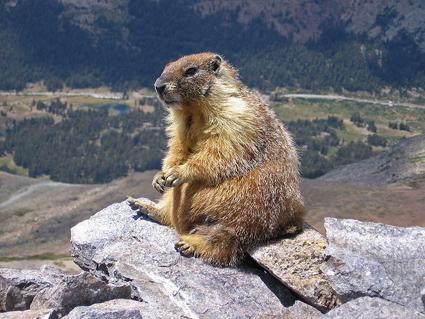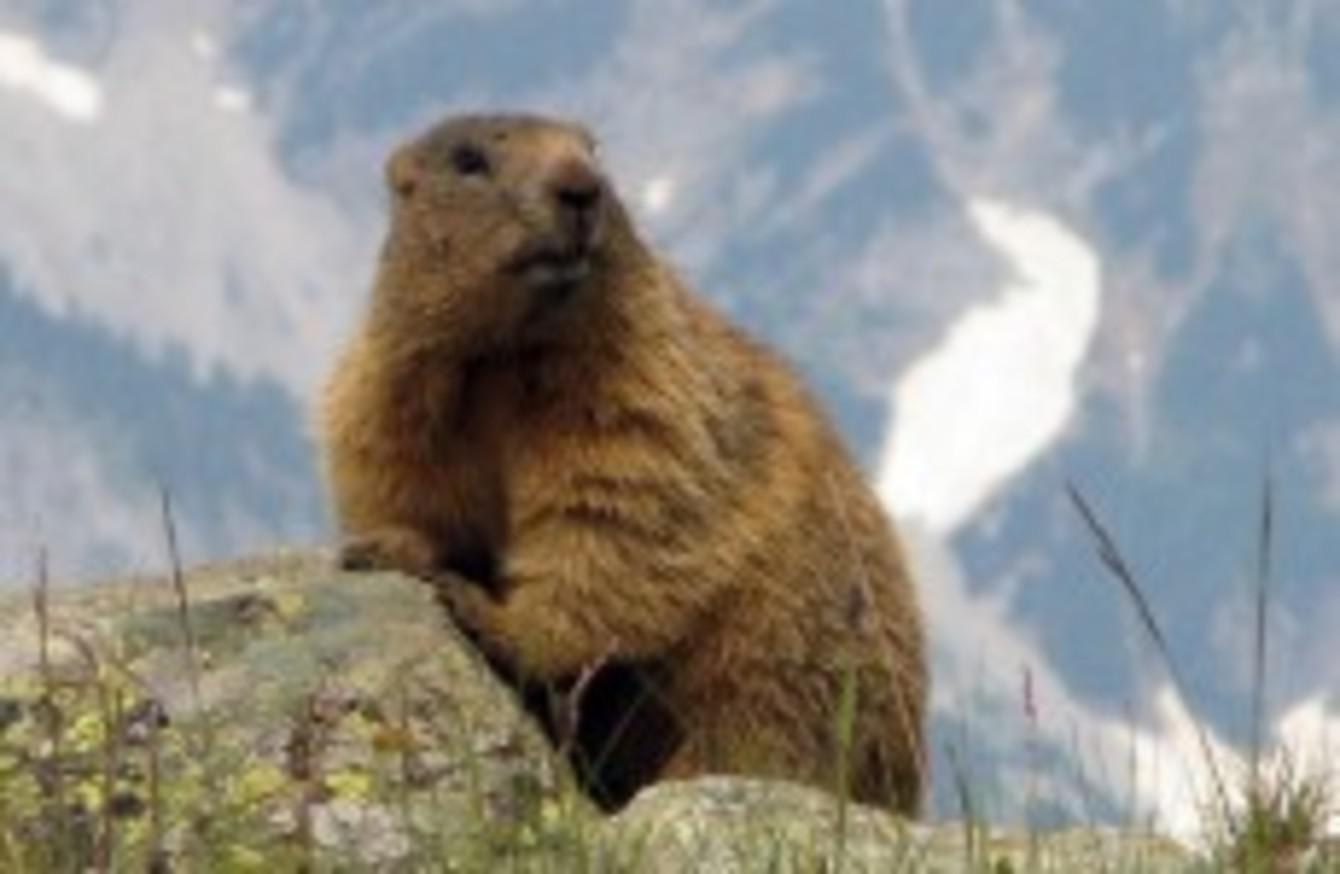The first image is the image on the left, the second image is the image on the right. Analyze the images presented: Is the assertion "Exactly one of the images has the animal with its front paws pressed up against a rock while the front paws are elevated higher than it's back paws." valid? Answer yes or no. Yes. 